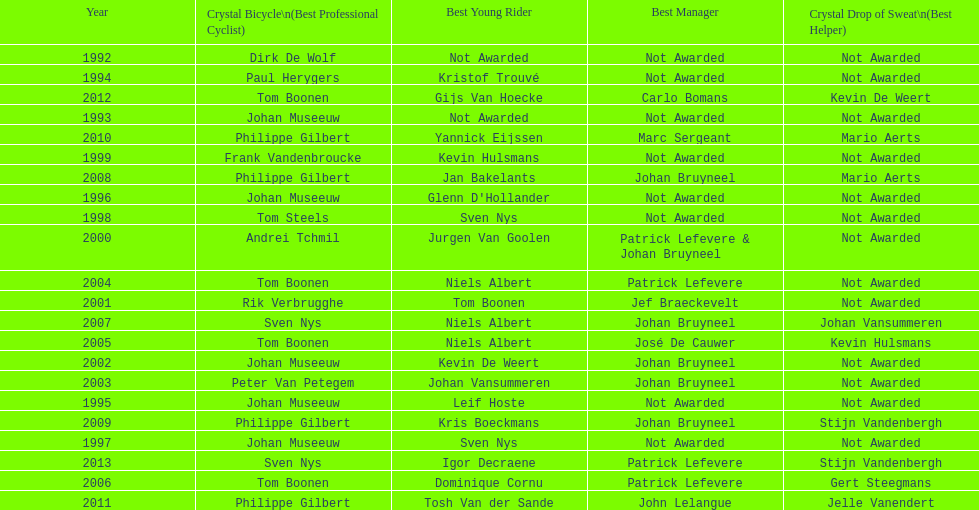Who won the crystal bicycle earlier, boonen or nys? Tom Boonen. 